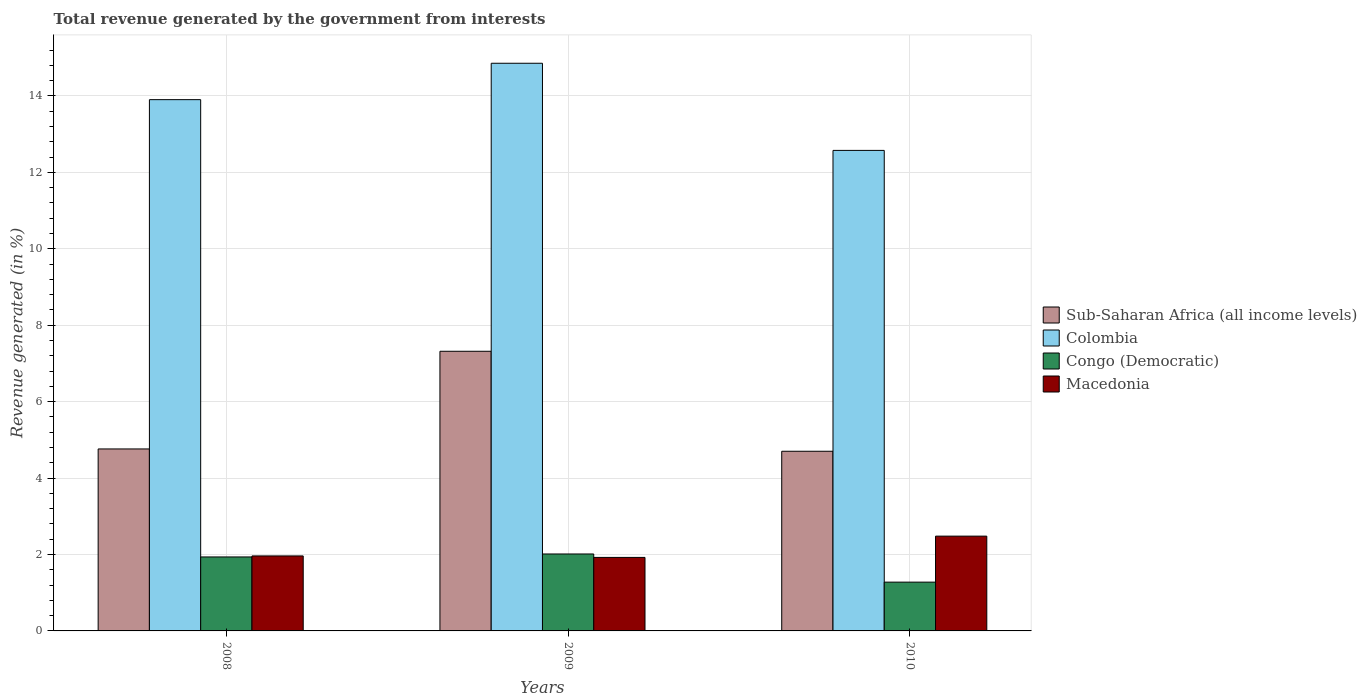Are the number of bars per tick equal to the number of legend labels?
Your answer should be compact. Yes. What is the label of the 1st group of bars from the left?
Provide a succinct answer. 2008. What is the total revenue generated in Sub-Saharan Africa (all income levels) in 2010?
Give a very brief answer. 4.7. Across all years, what is the maximum total revenue generated in Sub-Saharan Africa (all income levels)?
Make the answer very short. 7.32. Across all years, what is the minimum total revenue generated in Congo (Democratic)?
Provide a short and direct response. 1.28. In which year was the total revenue generated in Macedonia maximum?
Offer a very short reply. 2010. In which year was the total revenue generated in Colombia minimum?
Keep it short and to the point. 2010. What is the total total revenue generated in Colombia in the graph?
Provide a succinct answer. 41.33. What is the difference between the total revenue generated in Colombia in 2008 and that in 2009?
Keep it short and to the point. -0.95. What is the difference between the total revenue generated in Congo (Democratic) in 2008 and the total revenue generated in Macedonia in 2010?
Your answer should be compact. -0.54. What is the average total revenue generated in Sub-Saharan Africa (all income levels) per year?
Provide a succinct answer. 5.59. In the year 2009, what is the difference between the total revenue generated in Macedonia and total revenue generated in Sub-Saharan Africa (all income levels)?
Your answer should be very brief. -5.39. What is the ratio of the total revenue generated in Congo (Democratic) in 2009 to that in 2010?
Ensure brevity in your answer.  1.58. Is the total revenue generated in Sub-Saharan Africa (all income levels) in 2008 less than that in 2009?
Provide a succinct answer. Yes. What is the difference between the highest and the second highest total revenue generated in Colombia?
Ensure brevity in your answer.  0.95. What is the difference between the highest and the lowest total revenue generated in Sub-Saharan Africa (all income levels)?
Ensure brevity in your answer.  2.62. Is the sum of the total revenue generated in Sub-Saharan Africa (all income levels) in 2008 and 2010 greater than the maximum total revenue generated in Colombia across all years?
Provide a short and direct response. No. Is it the case that in every year, the sum of the total revenue generated in Colombia and total revenue generated in Congo (Democratic) is greater than the sum of total revenue generated in Macedonia and total revenue generated in Sub-Saharan Africa (all income levels)?
Make the answer very short. Yes. What does the 1st bar from the left in 2009 represents?
Offer a very short reply. Sub-Saharan Africa (all income levels). What does the 2nd bar from the right in 2010 represents?
Your response must be concise. Congo (Democratic). How many years are there in the graph?
Give a very brief answer. 3. Does the graph contain any zero values?
Ensure brevity in your answer.  No. Where does the legend appear in the graph?
Offer a very short reply. Center right. What is the title of the graph?
Ensure brevity in your answer.  Total revenue generated by the government from interests. What is the label or title of the X-axis?
Keep it short and to the point. Years. What is the label or title of the Y-axis?
Make the answer very short. Revenue generated (in %). What is the Revenue generated (in %) in Sub-Saharan Africa (all income levels) in 2008?
Give a very brief answer. 4.76. What is the Revenue generated (in %) in Colombia in 2008?
Make the answer very short. 13.9. What is the Revenue generated (in %) in Congo (Democratic) in 2008?
Your answer should be very brief. 1.94. What is the Revenue generated (in %) in Macedonia in 2008?
Make the answer very short. 1.96. What is the Revenue generated (in %) of Sub-Saharan Africa (all income levels) in 2009?
Give a very brief answer. 7.32. What is the Revenue generated (in %) in Colombia in 2009?
Your answer should be very brief. 14.86. What is the Revenue generated (in %) of Congo (Democratic) in 2009?
Make the answer very short. 2.01. What is the Revenue generated (in %) of Macedonia in 2009?
Provide a succinct answer. 1.92. What is the Revenue generated (in %) in Sub-Saharan Africa (all income levels) in 2010?
Your answer should be very brief. 4.7. What is the Revenue generated (in %) of Colombia in 2010?
Your answer should be compact. 12.57. What is the Revenue generated (in %) of Congo (Democratic) in 2010?
Ensure brevity in your answer.  1.28. What is the Revenue generated (in %) in Macedonia in 2010?
Provide a succinct answer. 2.48. Across all years, what is the maximum Revenue generated (in %) in Sub-Saharan Africa (all income levels)?
Your answer should be compact. 7.32. Across all years, what is the maximum Revenue generated (in %) in Colombia?
Provide a succinct answer. 14.86. Across all years, what is the maximum Revenue generated (in %) of Congo (Democratic)?
Your answer should be very brief. 2.01. Across all years, what is the maximum Revenue generated (in %) in Macedonia?
Your answer should be compact. 2.48. Across all years, what is the minimum Revenue generated (in %) in Sub-Saharan Africa (all income levels)?
Keep it short and to the point. 4.7. Across all years, what is the minimum Revenue generated (in %) in Colombia?
Provide a short and direct response. 12.57. Across all years, what is the minimum Revenue generated (in %) of Congo (Democratic)?
Provide a short and direct response. 1.28. Across all years, what is the minimum Revenue generated (in %) in Macedonia?
Keep it short and to the point. 1.92. What is the total Revenue generated (in %) of Sub-Saharan Africa (all income levels) in the graph?
Make the answer very short. 16.78. What is the total Revenue generated (in %) in Colombia in the graph?
Keep it short and to the point. 41.33. What is the total Revenue generated (in %) in Congo (Democratic) in the graph?
Offer a terse response. 5.23. What is the total Revenue generated (in %) in Macedonia in the graph?
Offer a very short reply. 6.37. What is the difference between the Revenue generated (in %) of Sub-Saharan Africa (all income levels) in 2008 and that in 2009?
Keep it short and to the point. -2.56. What is the difference between the Revenue generated (in %) of Colombia in 2008 and that in 2009?
Offer a terse response. -0.95. What is the difference between the Revenue generated (in %) in Congo (Democratic) in 2008 and that in 2009?
Provide a succinct answer. -0.08. What is the difference between the Revenue generated (in %) of Macedonia in 2008 and that in 2009?
Offer a terse response. 0.04. What is the difference between the Revenue generated (in %) of Sub-Saharan Africa (all income levels) in 2008 and that in 2010?
Offer a very short reply. 0.06. What is the difference between the Revenue generated (in %) in Colombia in 2008 and that in 2010?
Keep it short and to the point. 1.33. What is the difference between the Revenue generated (in %) of Congo (Democratic) in 2008 and that in 2010?
Offer a terse response. 0.66. What is the difference between the Revenue generated (in %) in Macedonia in 2008 and that in 2010?
Provide a short and direct response. -0.52. What is the difference between the Revenue generated (in %) in Sub-Saharan Africa (all income levels) in 2009 and that in 2010?
Your response must be concise. 2.62. What is the difference between the Revenue generated (in %) of Colombia in 2009 and that in 2010?
Offer a very short reply. 2.28. What is the difference between the Revenue generated (in %) in Congo (Democratic) in 2009 and that in 2010?
Your answer should be compact. 0.74. What is the difference between the Revenue generated (in %) in Macedonia in 2009 and that in 2010?
Your response must be concise. -0.56. What is the difference between the Revenue generated (in %) in Sub-Saharan Africa (all income levels) in 2008 and the Revenue generated (in %) in Colombia in 2009?
Ensure brevity in your answer.  -10.09. What is the difference between the Revenue generated (in %) in Sub-Saharan Africa (all income levels) in 2008 and the Revenue generated (in %) in Congo (Democratic) in 2009?
Your answer should be compact. 2.75. What is the difference between the Revenue generated (in %) in Sub-Saharan Africa (all income levels) in 2008 and the Revenue generated (in %) in Macedonia in 2009?
Keep it short and to the point. 2.84. What is the difference between the Revenue generated (in %) in Colombia in 2008 and the Revenue generated (in %) in Congo (Democratic) in 2009?
Your answer should be very brief. 11.89. What is the difference between the Revenue generated (in %) of Colombia in 2008 and the Revenue generated (in %) of Macedonia in 2009?
Your answer should be very brief. 11.98. What is the difference between the Revenue generated (in %) in Congo (Democratic) in 2008 and the Revenue generated (in %) in Macedonia in 2009?
Offer a very short reply. 0.01. What is the difference between the Revenue generated (in %) in Sub-Saharan Africa (all income levels) in 2008 and the Revenue generated (in %) in Colombia in 2010?
Your answer should be very brief. -7.81. What is the difference between the Revenue generated (in %) in Sub-Saharan Africa (all income levels) in 2008 and the Revenue generated (in %) in Congo (Democratic) in 2010?
Your answer should be very brief. 3.49. What is the difference between the Revenue generated (in %) of Sub-Saharan Africa (all income levels) in 2008 and the Revenue generated (in %) of Macedonia in 2010?
Offer a terse response. 2.28. What is the difference between the Revenue generated (in %) of Colombia in 2008 and the Revenue generated (in %) of Congo (Democratic) in 2010?
Provide a short and direct response. 12.63. What is the difference between the Revenue generated (in %) of Colombia in 2008 and the Revenue generated (in %) of Macedonia in 2010?
Your answer should be very brief. 11.42. What is the difference between the Revenue generated (in %) in Congo (Democratic) in 2008 and the Revenue generated (in %) in Macedonia in 2010?
Your response must be concise. -0.54. What is the difference between the Revenue generated (in %) of Sub-Saharan Africa (all income levels) in 2009 and the Revenue generated (in %) of Colombia in 2010?
Provide a short and direct response. -5.26. What is the difference between the Revenue generated (in %) in Sub-Saharan Africa (all income levels) in 2009 and the Revenue generated (in %) in Congo (Democratic) in 2010?
Provide a short and direct response. 6.04. What is the difference between the Revenue generated (in %) in Sub-Saharan Africa (all income levels) in 2009 and the Revenue generated (in %) in Macedonia in 2010?
Give a very brief answer. 4.84. What is the difference between the Revenue generated (in %) of Colombia in 2009 and the Revenue generated (in %) of Congo (Democratic) in 2010?
Provide a succinct answer. 13.58. What is the difference between the Revenue generated (in %) in Colombia in 2009 and the Revenue generated (in %) in Macedonia in 2010?
Ensure brevity in your answer.  12.37. What is the difference between the Revenue generated (in %) in Congo (Democratic) in 2009 and the Revenue generated (in %) in Macedonia in 2010?
Ensure brevity in your answer.  -0.47. What is the average Revenue generated (in %) of Sub-Saharan Africa (all income levels) per year?
Make the answer very short. 5.59. What is the average Revenue generated (in %) of Colombia per year?
Provide a succinct answer. 13.78. What is the average Revenue generated (in %) of Congo (Democratic) per year?
Offer a very short reply. 1.74. What is the average Revenue generated (in %) of Macedonia per year?
Provide a short and direct response. 2.12. In the year 2008, what is the difference between the Revenue generated (in %) of Sub-Saharan Africa (all income levels) and Revenue generated (in %) of Colombia?
Your answer should be very brief. -9.14. In the year 2008, what is the difference between the Revenue generated (in %) of Sub-Saharan Africa (all income levels) and Revenue generated (in %) of Congo (Democratic)?
Keep it short and to the point. 2.83. In the year 2008, what is the difference between the Revenue generated (in %) of Sub-Saharan Africa (all income levels) and Revenue generated (in %) of Macedonia?
Ensure brevity in your answer.  2.8. In the year 2008, what is the difference between the Revenue generated (in %) in Colombia and Revenue generated (in %) in Congo (Democratic)?
Provide a succinct answer. 11.97. In the year 2008, what is the difference between the Revenue generated (in %) of Colombia and Revenue generated (in %) of Macedonia?
Offer a terse response. 11.94. In the year 2008, what is the difference between the Revenue generated (in %) of Congo (Democratic) and Revenue generated (in %) of Macedonia?
Ensure brevity in your answer.  -0.03. In the year 2009, what is the difference between the Revenue generated (in %) in Sub-Saharan Africa (all income levels) and Revenue generated (in %) in Colombia?
Provide a short and direct response. -7.54. In the year 2009, what is the difference between the Revenue generated (in %) of Sub-Saharan Africa (all income levels) and Revenue generated (in %) of Congo (Democratic)?
Give a very brief answer. 5.3. In the year 2009, what is the difference between the Revenue generated (in %) in Sub-Saharan Africa (all income levels) and Revenue generated (in %) in Macedonia?
Provide a succinct answer. 5.39. In the year 2009, what is the difference between the Revenue generated (in %) of Colombia and Revenue generated (in %) of Congo (Democratic)?
Your response must be concise. 12.84. In the year 2009, what is the difference between the Revenue generated (in %) in Colombia and Revenue generated (in %) in Macedonia?
Ensure brevity in your answer.  12.93. In the year 2009, what is the difference between the Revenue generated (in %) in Congo (Democratic) and Revenue generated (in %) in Macedonia?
Your response must be concise. 0.09. In the year 2010, what is the difference between the Revenue generated (in %) in Sub-Saharan Africa (all income levels) and Revenue generated (in %) in Colombia?
Offer a very short reply. -7.87. In the year 2010, what is the difference between the Revenue generated (in %) of Sub-Saharan Africa (all income levels) and Revenue generated (in %) of Congo (Democratic)?
Offer a very short reply. 3.42. In the year 2010, what is the difference between the Revenue generated (in %) of Sub-Saharan Africa (all income levels) and Revenue generated (in %) of Macedonia?
Your answer should be very brief. 2.22. In the year 2010, what is the difference between the Revenue generated (in %) in Colombia and Revenue generated (in %) in Congo (Democratic)?
Offer a terse response. 11.3. In the year 2010, what is the difference between the Revenue generated (in %) in Colombia and Revenue generated (in %) in Macedonia?
Provide a succinct answer. 10.09. In the year 2010, what is the difference between the Revenue generated (in %) in Congo (Democratic) and Revenue generated (in %) in Macedonia?
Your response must be concise. -1.2. What is the ratio of the Revenue generated (in %) of Sub-Saharan Africa (all income levels) in 2008 to that in 2009?
Your response must be concise. 0.65. What is the ratio of the Revenue generated (in %) of Colombia in 2008 to that in 2009?
Your answer should be compact. 0.94. What is the ratio of the Revenue generated (in %) of Congo (Democratic) in 2008 to that in 2009?
Your answer should be compact. 0.96. What is the ratio of the Revenue generated (in %) of Macedonia in 2008 to that in 2009?
Make the answer very short. 1.02. What is the ratio of the Revenue generated (in %) of Sub-Saharan Africa (all income levels) in 2008 to that in 2010?
Your response must be concise. 1.01. What is the ratio of the Revenue generated (in %) in Colombia in 2008 to that in 2010?
Your answer should be very brief. 1.11. What is the ratio of the Revenue generated (in %) of Congo (Democratic) in 2008 to that in 2010?
Your response must be concise. 1.52. What is the ratio of the Revenue generated (in %) in Macedonia in 2008 to that in 2010?
Provide a succinct answer. 0.79. What is the ratio of the Revenue generated (in %) of Sub-Saharan Africa (all income levels) in 2009 to that in 2010?
Your answer should be very brief. 1.56. What is the ratio of the Revenue generated (in %) of Colombia in 2009 to that in 2010?
Your answer should be compact. 1.18. What is the ratio of the Revenue generated (in %) of Congo (Democratic) in 2009 to that in 2010?
Your answer should be very brief. 1.58. What is the ratio of the Revenue generated (in %) of Macedonia in 2009 to that in 2010?
Ensure brevity in your answer.  0.78. What is the difference between the highest and the second highest Revenue generated (in %) in Sub-Saharan Africa (all income levels)?
Give a very brief answer. 2.56. What is the difference between the highest and the second highest Revenue generated (in %) of Colombia?
Make the answer very short. 0.95. What is the difference between the highest and the second highest Revenue generated (in %) in Congo (Democratic)?
Keep it short and to the point. 0.08. What is the difference between the highest and the second highest Revenue generated (in %) in Macedonia?
Offer a terse response. 0.52. What is the difference between the highest and the lowest Revenue generated (in %) in Sub-Saharan Africa (all income levels)?
Give a very brief answer. 2.62. What is the difference between the highest and the lowest Revenue generated (in %) in Colombia?
Provide a succinct answer. 2.28. What is the difference between the highest and the lowest Revenue generated (in %) in Congo (Democratic)?
Offer a terse response. 0.74. What is the difference between the highest and the lowest Revenue generated (in %) of Macedonia?
Your answer should be very brief. 0.56. 